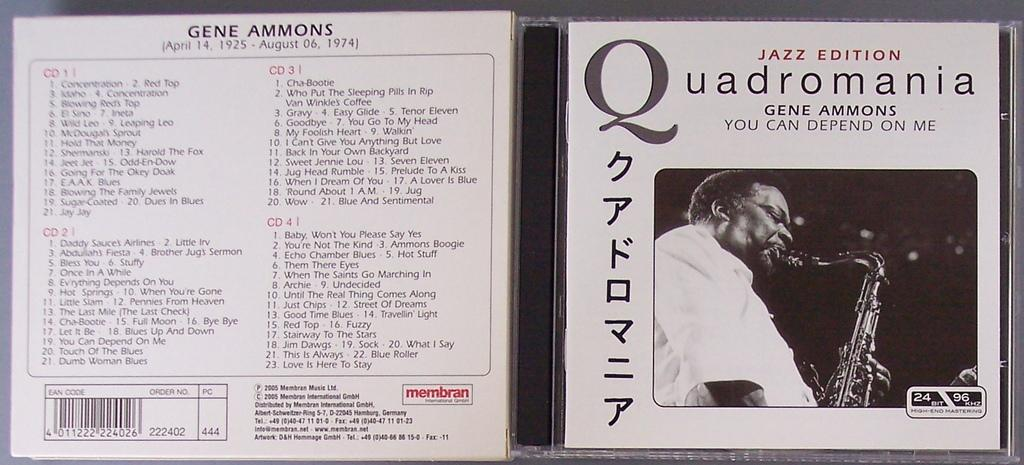<image>
Summarize the visual content of the image. an open case for the album Quadromania jazz edition. 